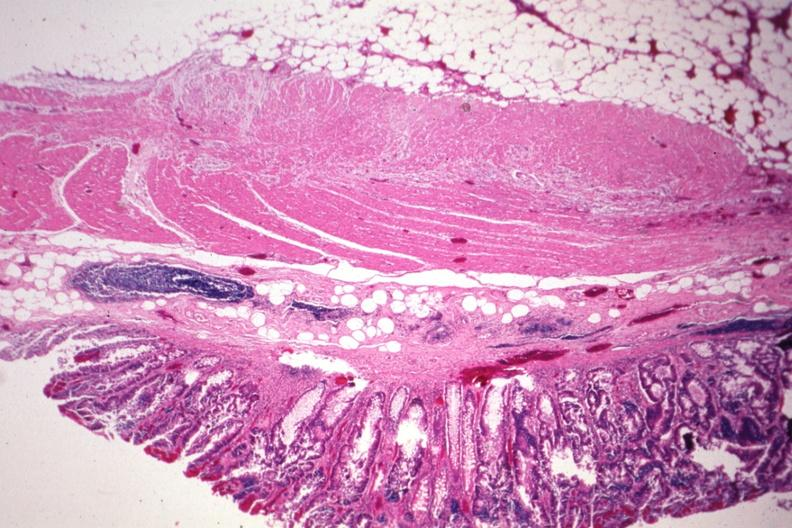what does this image show?
Answer the question using a single word or phrase. Nice photo with obvious tumor in mucosa 